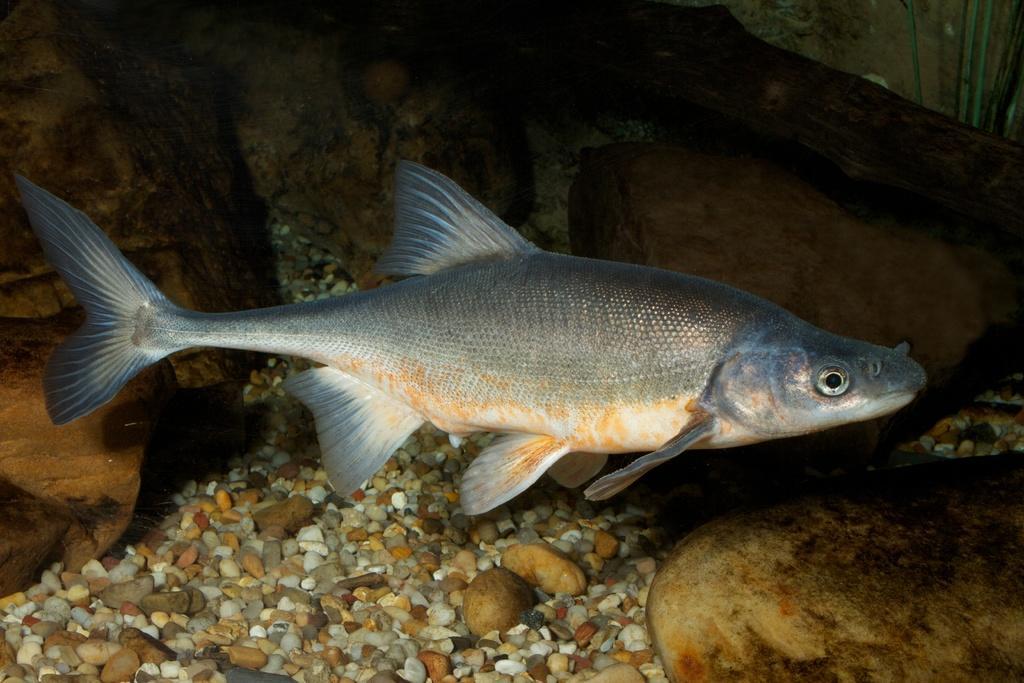Could you give a brief overview of what you see in this image? In this image I can see a fish which is grey, cream, orange and black in color is in the water. I can see few stones and few rocks which are cream, brown and orange in color. 